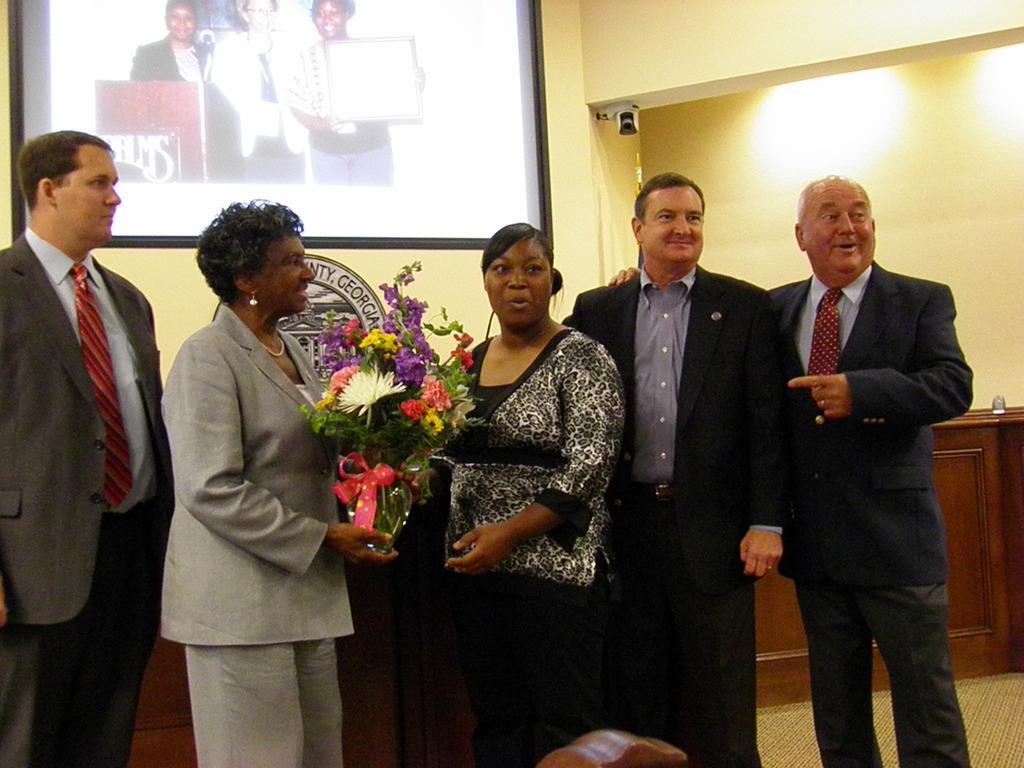Please provide a concise description of this image. In this image we can see few people standing. A person is holding a bouquet. There is an object on the wall at the right side of the image. There is a projector screen in the image. We can see few people on the projector screen. There is a podium in the image. On projector screen we can see few people holding an object. 